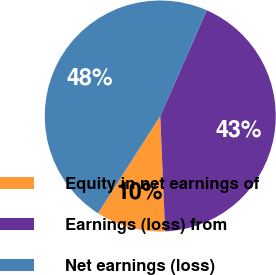<chart> <loc_0><loc_0><loc_500><loc_500><pie_chart><fcel>Equity in net earnings of<fcel>Earnings (loss) from<fcel>Net earnings (loss)<nl><fcel>9.73%<fcel>42.74%<fcel>47.54%<nl></chart> 